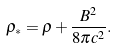Convert formula to latex. <formula><loc_0><loc_0><loc_500><loc_500>\rho _ { * } = \rho + \frac { B ^ { 2 } } { 8 \pi c ^ { 2 } } .</formula> 